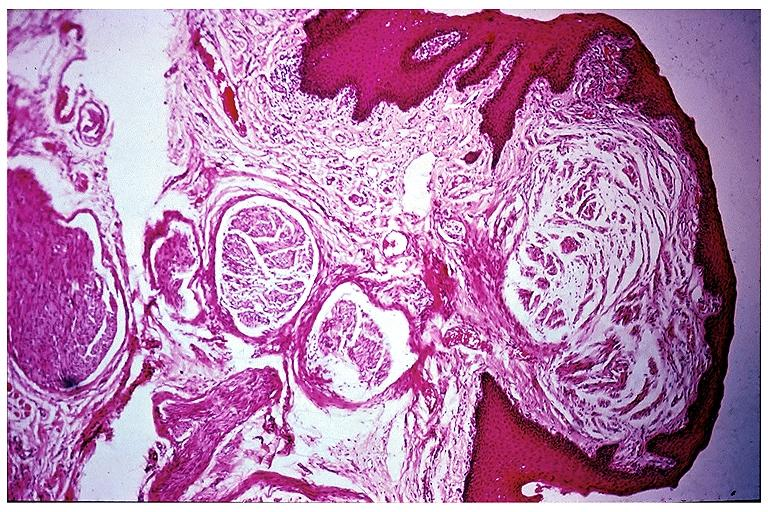s oral present?
Answer the question using a single word or phrase. Yes 